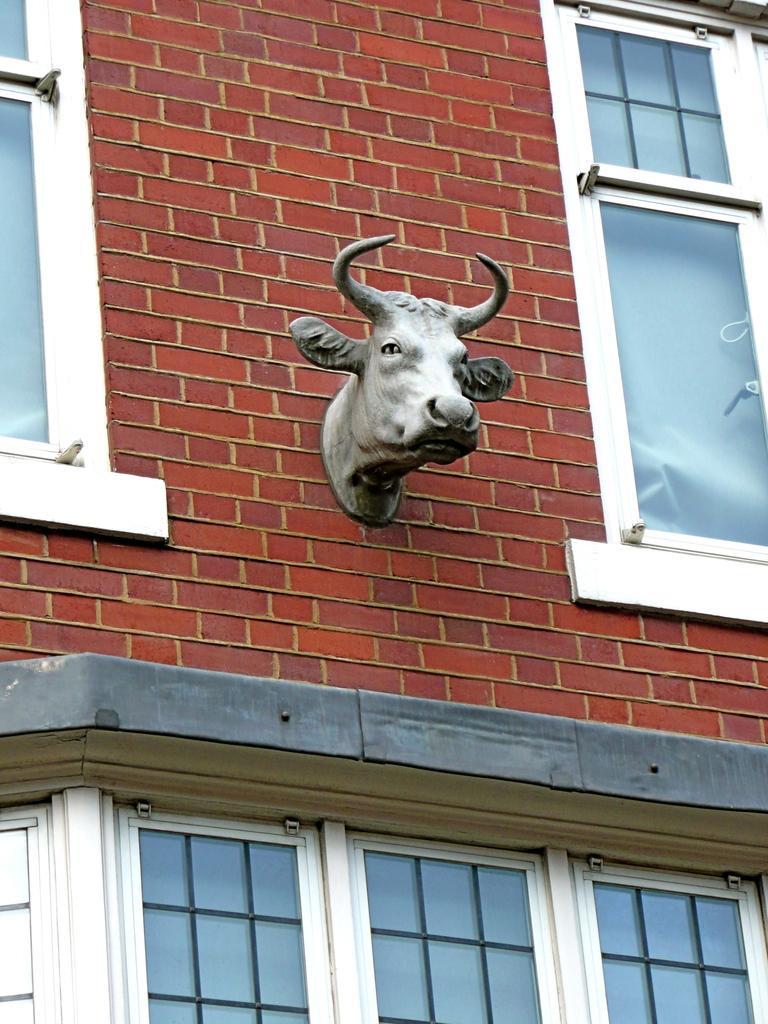Can you describe this image briefly? In this picture there is a face toy of an animal which is attached to the wall behind it and there are few windows beside and below it. 